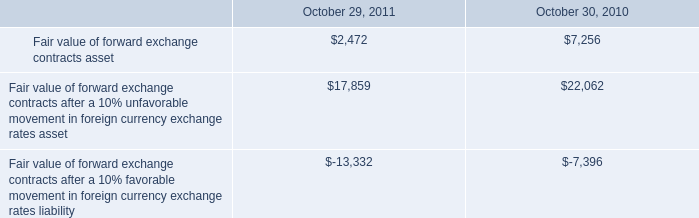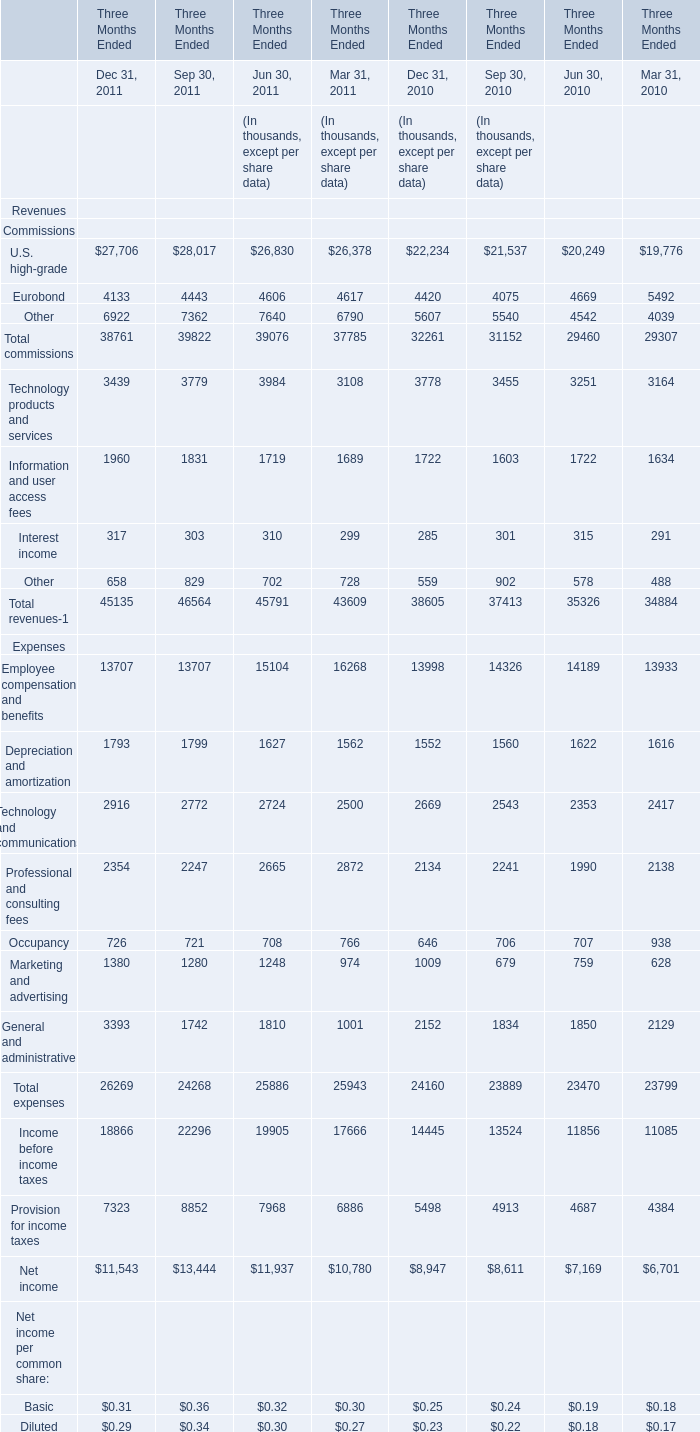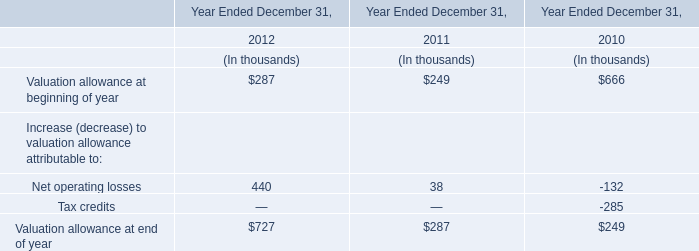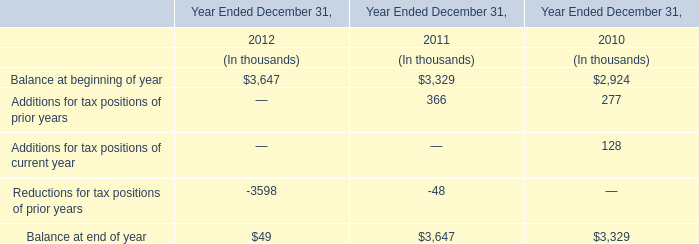what is the yearly interest expense incurred from the $ 375 million note with a fixed rate? 
Computations: (375 * 3%)
Answer: 11.25. 